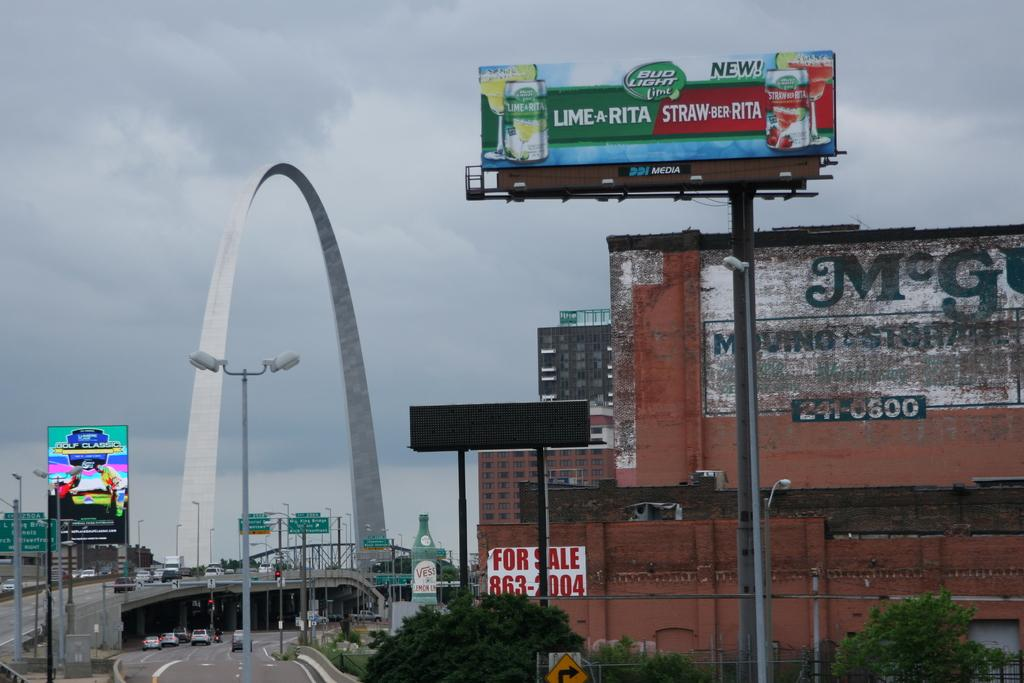<image>
Write a terse but informative summary of the picture. Several billboards, one for Bud Light limarita and strawberryrita. 